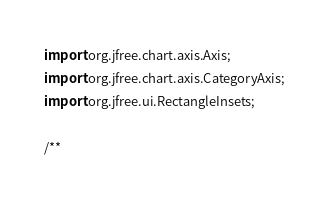Convert code to text. <code><loc_0><loc_0><loc_500><loc_500><_Java_>import org.jfree.chart.axis.Axis;
import org.jfree.chart.axis.CategoryAxis;
import org.jfree.ui.RectangleInsets;

/**</code> 